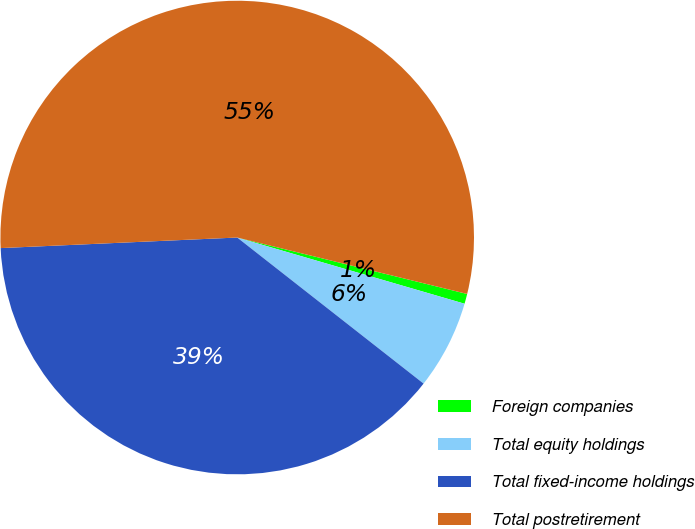Convert chart to OTSL. <chart><loc_0><loc_0><loc_500><loc_500><pie_chart><fcel>Foreign companies<fcel>Total equity holdings<fcel>Total fixed-income holdings<fcel>Total postretirement<nl><fcel>0.68%<fcel>6.07%<fcel>38.71%<fcel>54.54%<nl></chart> 